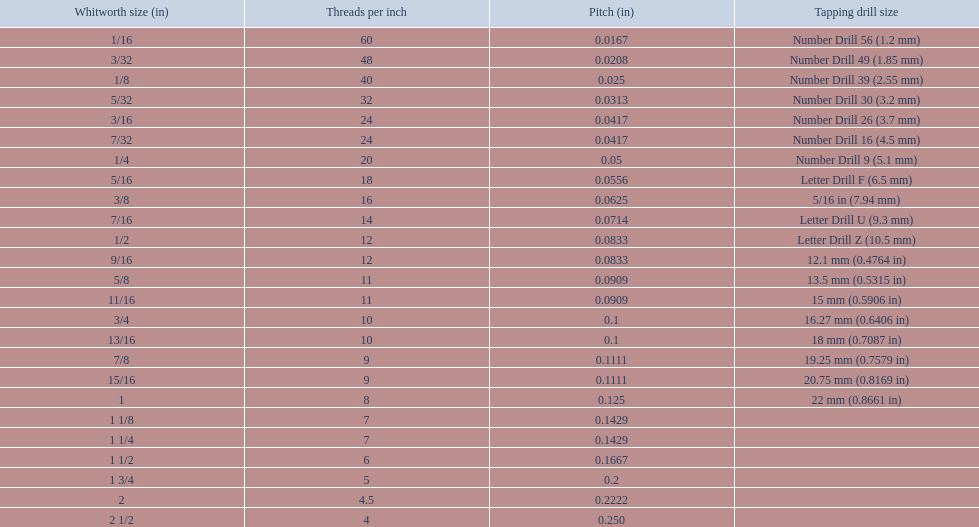What are the whitworth sizes? 1/16, 3/32, 1/8, 5/32, 3/16, 7/32, 1/4, 5/16, 3/8, 7/16, 1/2, 9/16, 5/8, 11/16, 3/4, 13/16, 7/8, 15/16, 1, 1 1/8, 1 1/4, 1 1/2, 1 3/4, 2, 2 1/2. And their threads per inch? 60, 48, 40, 32, 24, 24, 20, 18, 16, 14, 12, 12, 11, 11, 10, 10, 9, 9, 8, 7, 7, 6, 5, 4.5, 4. Could you parse the entire table? {'header': ['Whitworth size (in)', 'Threads per\xa0inch', 'Pitch (in)', 'Tapping drill size'], 'rows': [['1/16', '60', '0.0167', 'Number Drill 56 (1.2\xa0mm)'], ['3/32', '48', '0.0208', 'Number Drill 49 (1.85\xa0mm)'], ['1/8', '40', '0.025', 'Number Drill 39 (2.55\xa0mm)'], ['5/32', '32', '0.0313', 'Number Drill 30 (3.2\xa0mm)'], ['3/16', '24', '0.0417', 'Number Drill 26 (3.7\xa0mm)'], ['7/32', '24', '0.0417', 'Number Drill 16 (4.5\xa0mm)'], ['1/4', '20', '0.05', 'Number Drill 9 (5.1\xa0mm)'], ['5/16', '18', '0.0556', 'Letter Drill F (6.5\xa0mm)'], ['3/8', '16', '0.0625', '5/16\xa0in (7.94\xa0mm)'], ['7/16', '14', '0.0714', 'Letter Drill U (9.3\xa0mm)'], ['1/2', '12', '0.0833', 'Letter Drill Z (10.5\xa0mm)'], ['9/16', '12', '0.0833', '12.1\xa0mm (0.4764\xa0in)'], ['5/8', '11', '0.0909', '13.5\xa0mm (0.5315\xa0in)'], ['11/16', '11', '0.0909', '15\xa0mm (0.5906\xa0in)'], ['3/4', '10', '0.1', '16.27\xa0mm (0.6406\xa0in)'], ['13/16', '10', '0.1', '18\xa0mm (0.7087\xa0in)'], ['7/8', '9', '0.1111', '19.25\xa0mm (0.7579\xa0in)'], ['15/16', '9', '0.1111', '20.75\xa0mm (0.8169\xa0in)'], ['1', '8', '0.125', '22\xa0mm (0.8661\xa0in)'], ['1 1/8', '7', '0.1429', ''], ['1 1/4', '7', '0.1429', ''], ['1 1/2', '6', '0.1667', ''], ['1 3/4', '5', '0.2', ''], ['2', '4.5', '0.2222', ''], ['2 1/2', '4', '0.250', '']]} Now, which whitworth size has a thread-per-inch size of 5?? 1 3/4. 